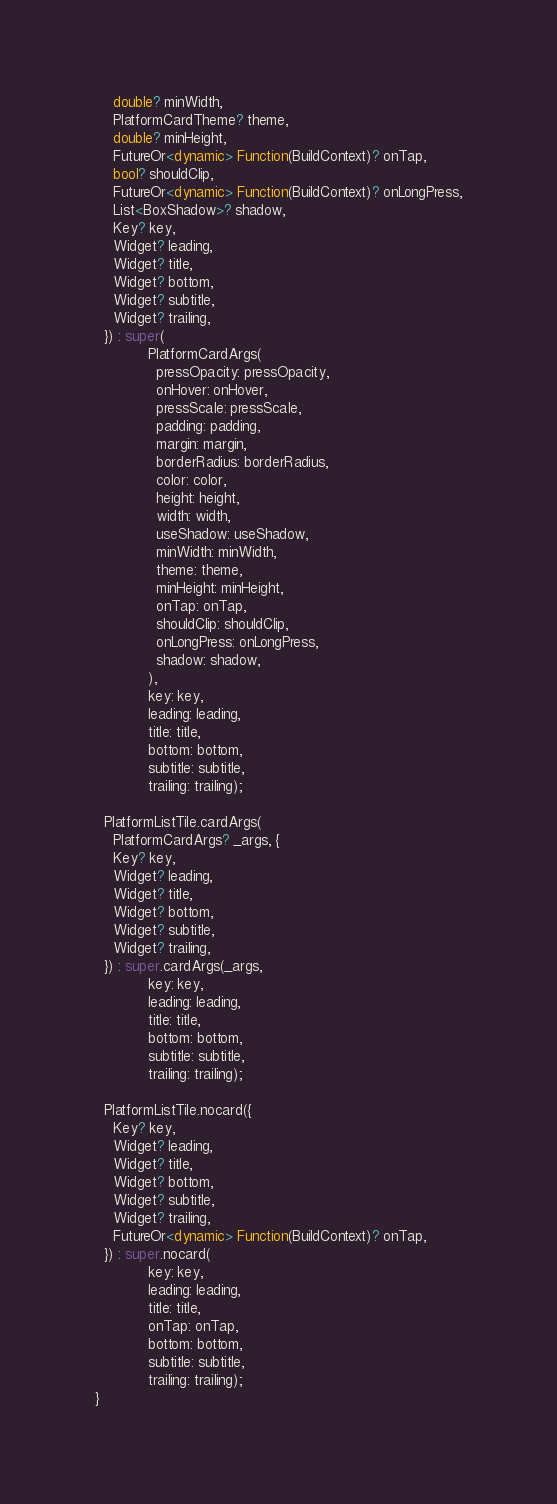Convert code to text. <code><loc_0><loc_0><loc_500><loc_500><_Dart_>    double? minWidth,
    PlatformCardTheme? theme,
    double? minHeight,
    FutureOr<dynamic> Function(BuildContext)? onTap,
    bool? shouldClip,
    FutureOr<dynamic> Function(BuildContext)? onLongPress,
    List<BoxShadow>? shadow,
    Key? key,
    Widget? leading,
    Widget? title,
    Widget? bottom,
    Widget? subtitle,
    Widget? trailing,
  }) : super(
            PlatformCardArgs(
              pressOpacity: pressOpacity,
              onHover: onHover,
              pressScale: pressScale,
              padding: padding,
              margin: margin,
              borderRadius: borderRadius,
              color: color,
              height: height,
              width: width,
              useShadow: useShadow,
              minWidth: minWidth,
              theme: theme,
              minHeight: minHeight,
              onTap: onTap,
              shouldClip: shouldClip,
              onLongPress: onLongPress,
              shadow: shadow,
            ),
            key: key,
            leading: leading,
            title: title,
            bottom: bottom,
            subtitle: subtitle,
            trailing: trailing);

  PlatformListTile.cardArgs(
    PlatformCardArgs? _args, {
    Key? key,
    Widget? leading,
    Widget? title,
    Widget? bottom,
    Widget? subtitle,
    Widget? trailing,
  }) : super.cardArgs(_args,
            key: key,
            leading: leading,
            title: title,
            bottom: bottom,
            subtitle: subtitle,
            trailing: trailing);

  PlatformListTile.nocard({
    Key? key,
    Widget? leading,
    Widget? title,
    Widget? bottom,
    Widget? subtitle,
    Widget? trailing,
    FutureOr<dynamic> Function(BuildContext)? onTap,
  }) : super.nocard(
            key: key,
            leading: leading,
            title: title,
            onTap: onTap,
            bottom: bottom,
            subtitle: subtitle,
            trailing: trailing);
}
</code> 